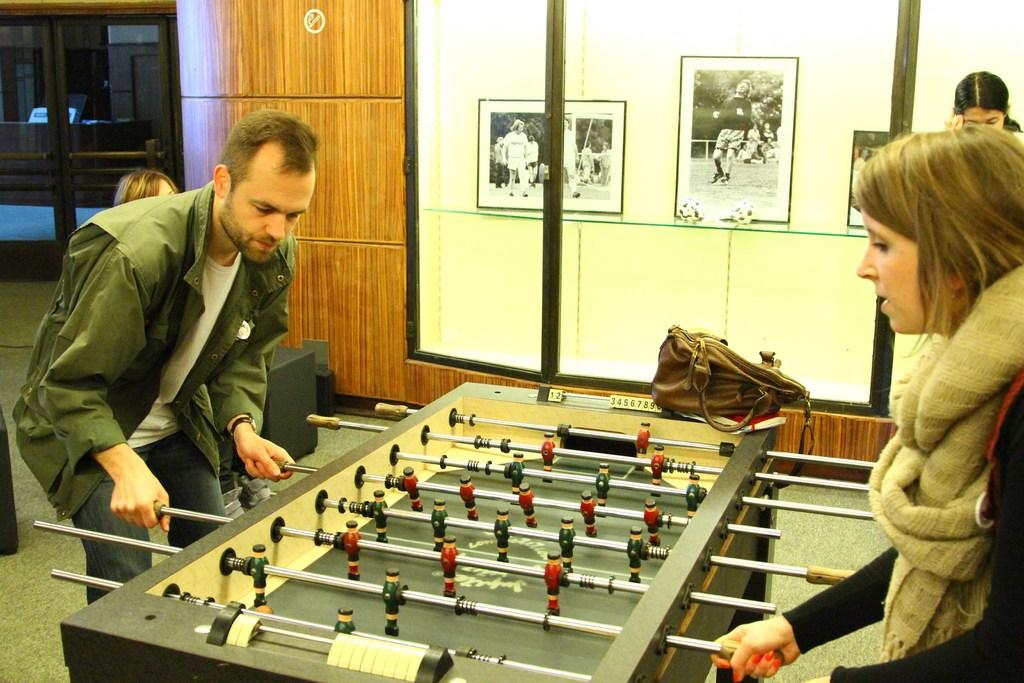What are the man and woman in the image doing? The man and woman are playing a game in the image. Where is the game being played? The game is being played on a table. Can you describe the people in the background of the image? There is a woman standing behind the players in the image. What can be seen on the wall in the image? There are photo frames on the wall in the image. What color is the dress worn by the mice in the image? There are no mice, let alone dressed mice, present in the image. 